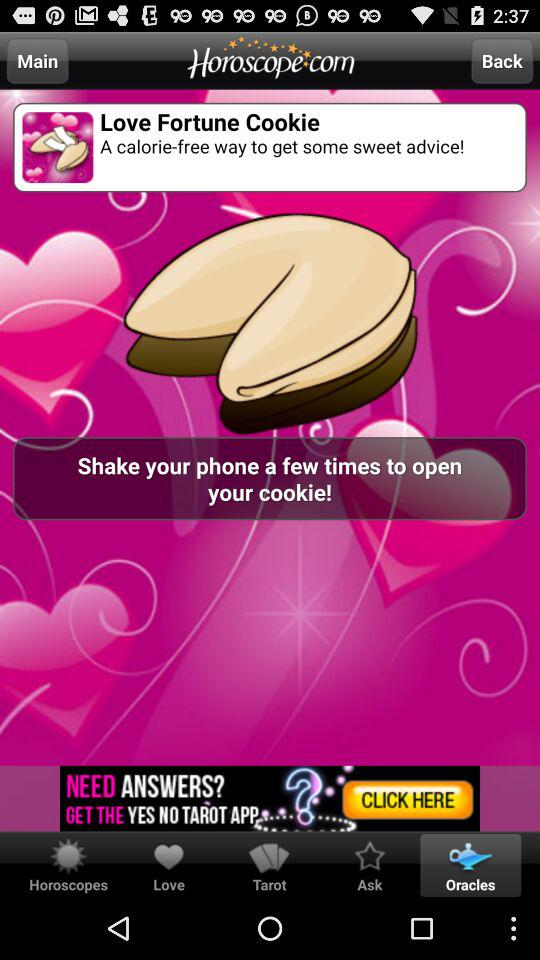Which tab is selected? The selected tab is "Oracles". 